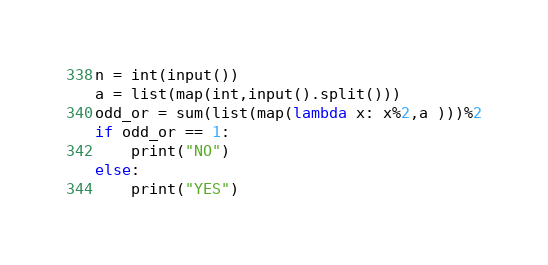<code> <loc_0><loc_0><loc_500><loc_500><_Python_>n = int(input())
a = list(map(int,input().split()))
odd_or = sum(list(map(lambda x: x%2,a )))%2
if odd_or == 1:
    print("NO")
else:
    print("YES")
</code> 